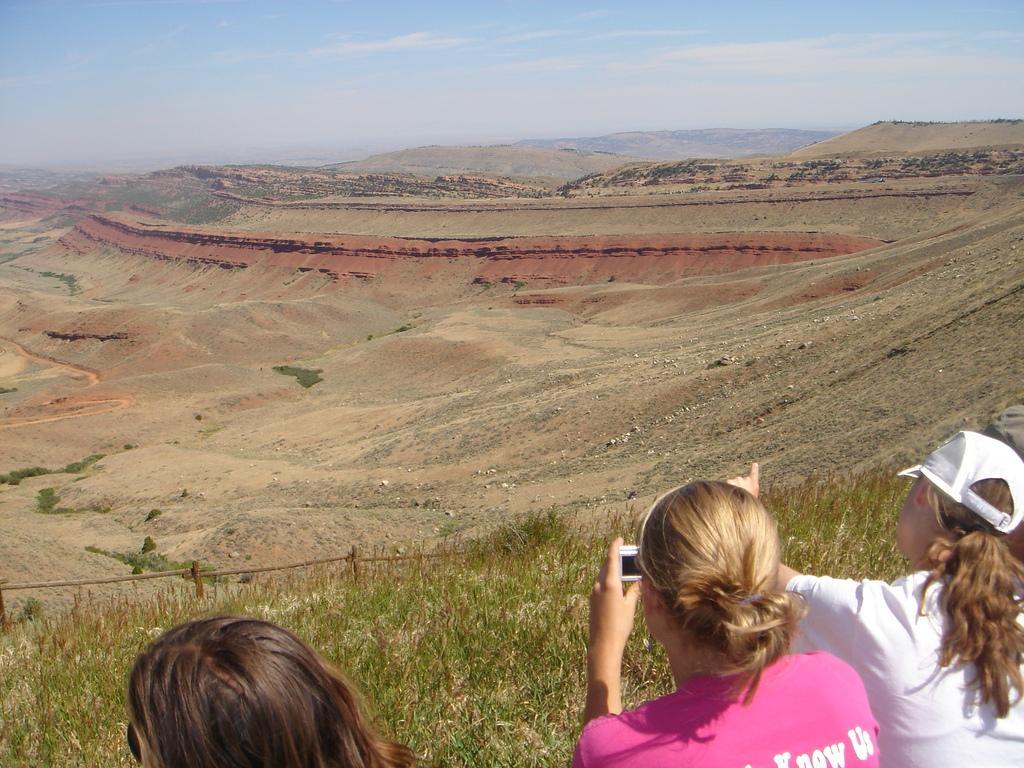Describe this image in one or two sentences. In the image we can see there are people standing on the ground and a woman is holding camera in her hand. The ground is covered with grass and behind there is a mud on the ground. 